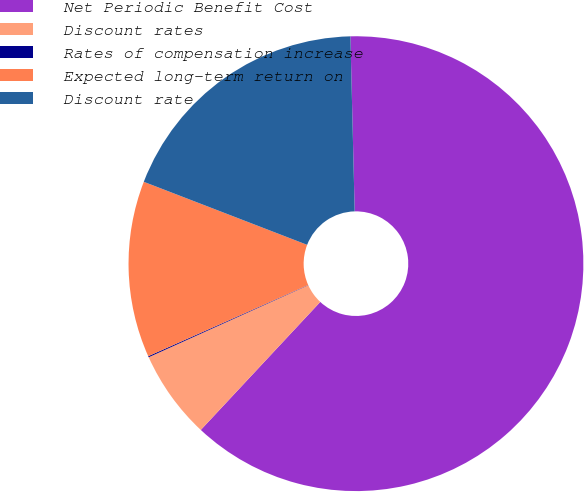Convert chart. <chart><loc_0><loc_0><loc_500><loc_500><pie_chart><fcel>Net Periodic Benefit Cost<fcel>Discount rates<fcel>Rates of compensation increase<fcel>Expected long-term return on<fcel>Discount rate<nl><fcel>62.34%<fcel>6.3%<fcel>0.08%<fcel>12.53%<fcel>18.75%<nl></chart> 